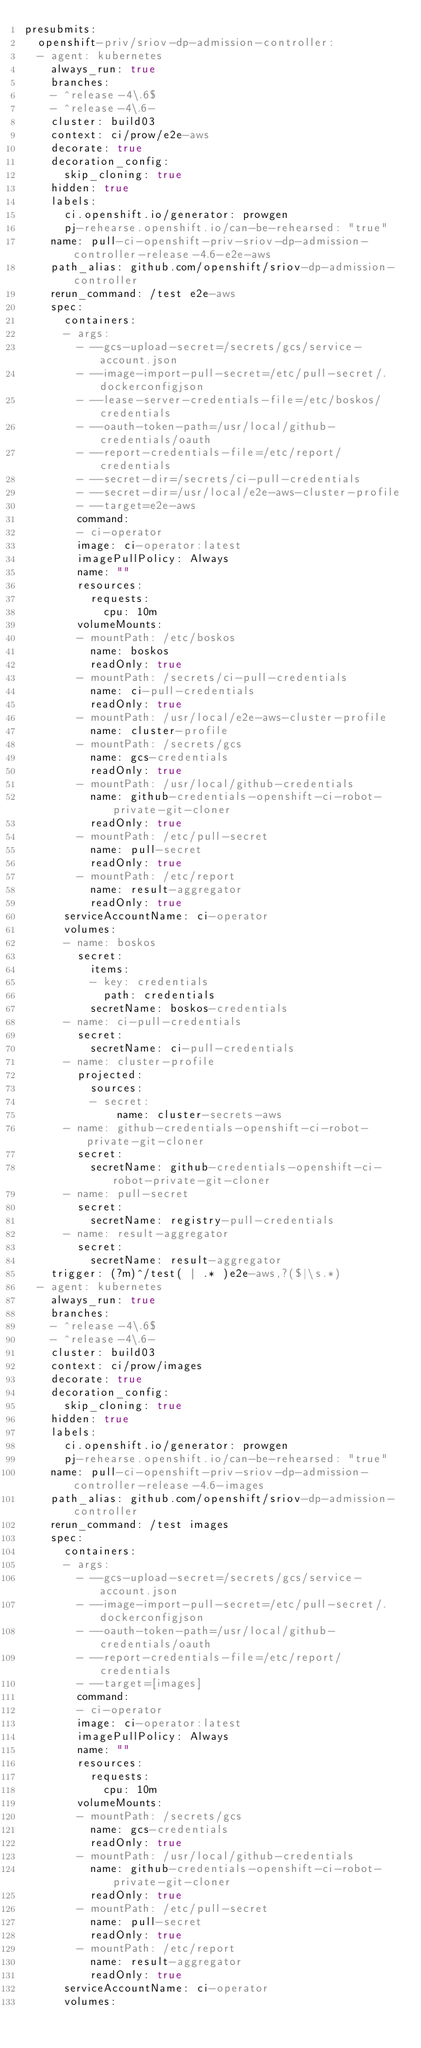<code> <loc_0><loc_0><loc_500><loc_500><_YAML_>presubmits:
  openshift-priv/sriov-dp-admission-controller:
  - agent: kubernetes
    always_run: true
    branches:
    - ^release-4\.6$
    - ^release-4\.6-
    cluster: build03
    context: ci/prow/e2e-aws
    decorate: true
    decoration_config:
      skip_cloning: true
    hidden: true
    labels:
      ci.openshift.io/generator: prowgen
      pj-rehearse.openshift.io/can-be-rehearsed: "true"
    name: pull-ci-openshift-priv-sriov-dp-admission-controller-release-4.6-e2e-aws
    path_alias: github.com/openshift/sriov-dp-admission-controller
    rerun_command: /test e2e-aws
    spec:
      containers:
      - args:
        - --gcs-upload-secret=/secrets/gcs/service-account.json
        - --image-import-pull-secret=/etc/pull-secret/.dockerconfigjson
        - --lease-server-credentials-file=/etc/boskos/credentials
        - --oauth-token-path=/usr/local/github-credentials/oauth
        - --report-credentials-file=/etc/report/credentials
        - --secret-dir=/secrets/ci-pull-credentials
        - --secret-dir=/usr/local/e2e-aws-cluster-profile
        - --target=e2e-aws
        command:
        - ci-operator
        image: ci-operator:latest
        imagePullPolicy: Always
        name: ""
        resources:
          requests:
            cpu: 10m
        volumeMounts:
        - mountPath: /etc/boskos
          name: boskos
          readOnly: true
        - mountPath: /secrets/ci-pull-credentials
          name: ci-pull-credentials
          readOnly: true
        - mountPath: /usr/local/e2e-aws-cluster-profile
          name: cluster-profile
        - mountPath: /secrets/gcs
          name: gcs-credentials
          readOnly: true
        - mountPath: /usr/local/github-credentials
          name: github-credentials-openshift-ci-robot-private-git-cloner
          readOnly: true
        - mountPath: /etc/pull-secret
          name: pull-secret
          readOnly: true
        - mountPath: /etc/report
          name: result-aggregator
          readOnly: true
      serviceAccountName: ci-operator
      volumes:
      - name: boskos
        secret:
          items:
          - key: credentials
            path: credentials
          secretName: boskos-credentials
      - name: ci-pull-credentials
        secret:
          secretName: ci-pull-credentials
      - name: cluster-profile
        projected:
          sources:
          - secret:
              name: cluster-secrets-aws
      - name: github-credentials-openshift-ci-robot-private-git-cloner
        secret:
          secretName: github-credentials-openshift-ci-robot-private-git-cloner
      - name: pull-secret
        secret:
          secretName: registry-pull-credentials
      - name: result-aggregator
        secret:
          secretName: result-aggregator
    trigger: (?m)^/test( | .* )e2e-aws,?($|\s.*)
  - agent: kubernetes
    always_run: true
    branches:
    - ^release-4\.6$
    - ^release-4\.6-
    cluster: build03
    context: ci/prow/images
    decorate: true
    decoration_config:
      skip_cloning: true
    hidden: true
    labels:
      ci.openshift.io/generator: prowgen
      pj-rehearse.openshift.io/can-be-rehearsed: "true"
    name: pull-ci-openshift-priv-sriov-dp-admission-controller-release-4.6-images
    path_alias: github.com/openshift/sriov-dp-admission-controller
    rerun_command: /test images
    spec:
      containers:
      - args:
        - --gcs-upload-secret=/secrets/gcs/service-account.json
        - --image-import-pull-secret=/etc/pull-secret/.dockerconfigjson
        - --oauth-token-path=/usr/local/github-credentials/oauth
        - --report-credentials-file=/etc/report/credentials
        - --target=[images]
        command:
        - ci-operator
        image: ci-operator:latest
        imagePullPolicy: Always
        name: ""
        resources:
          requests:
            cpu: 10m
        volumeMounts:
        - mountPath: /secrets/gcs
          name: gcs-credentials
          readOnly: true
        - mountPath: /usr/local/github-credentials
          name: github-credentials-openshift-ci-robot-private-git-cloner
          readOnly: true
        - mountPath: /etc/pull-secret
          name: pull-secret
          readOnly: true
        - mountPath: /etc/report
          name: result-aggregator
          readOnly: true
      serviceAccountName: ci-operator
      volumes:</code> 